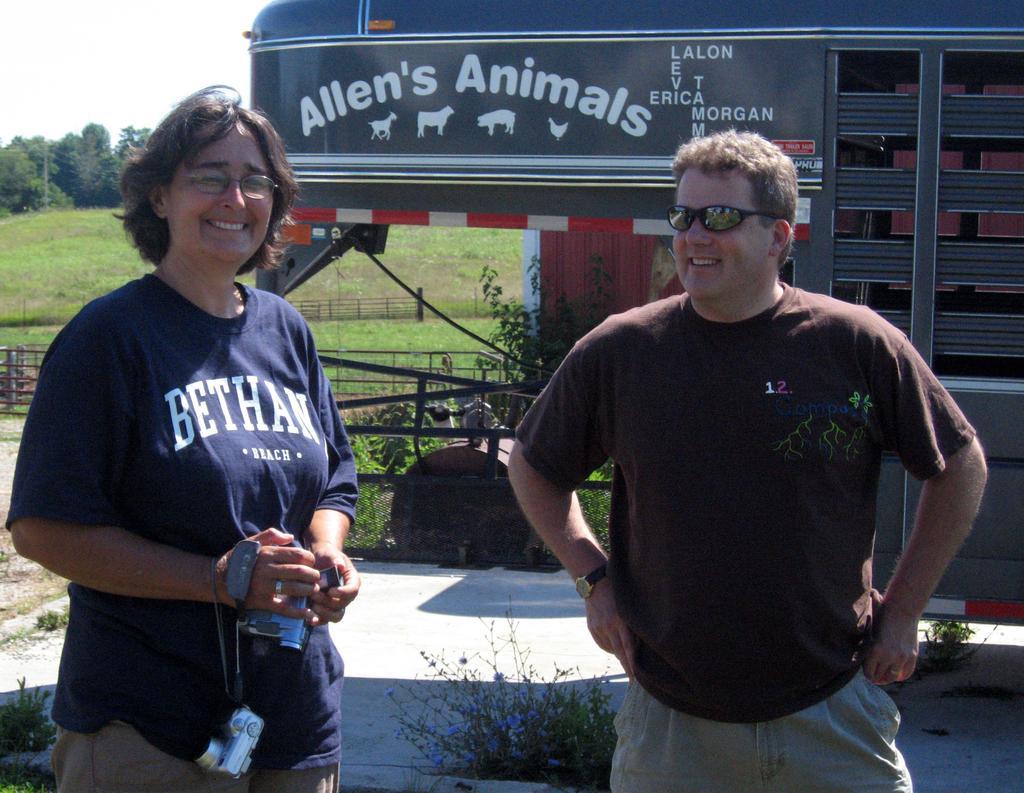Can you describe this image briefly? In this image I can see two persons. The persons at right wearing brown shirt, cream pant and the person at left wearing blue shirt, cream pant. At the back I can see a stall and a board in gray color and trees in green color and sky in white color. 